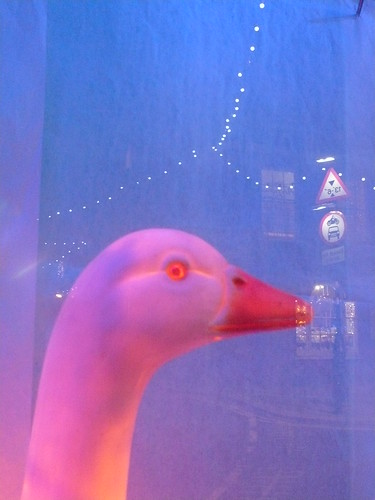Could this toy be part of a larger collection or theme? What elements in the image suggest this? It's likely that this toy is part of a larger collection or theme. The background features a warning sign that hints at a specific setting—perhaps a thematic park or an educational series aimed at young children. These elements suggest a possible theme around wildlife or outdoor exploration. 